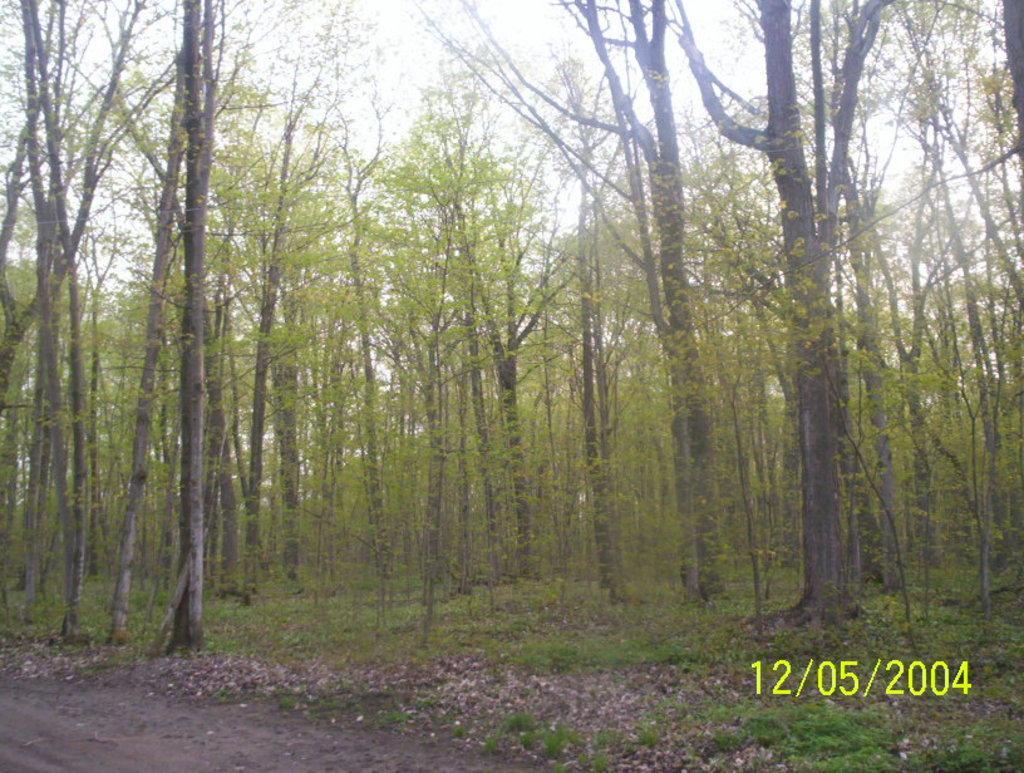In one or two sentences, can you explain what this image depicts? In this picture there are a group of trees, at the bottom there is a walkway grass and dry leaves. At the bottom of the image there is text, and at the top there is sky. 